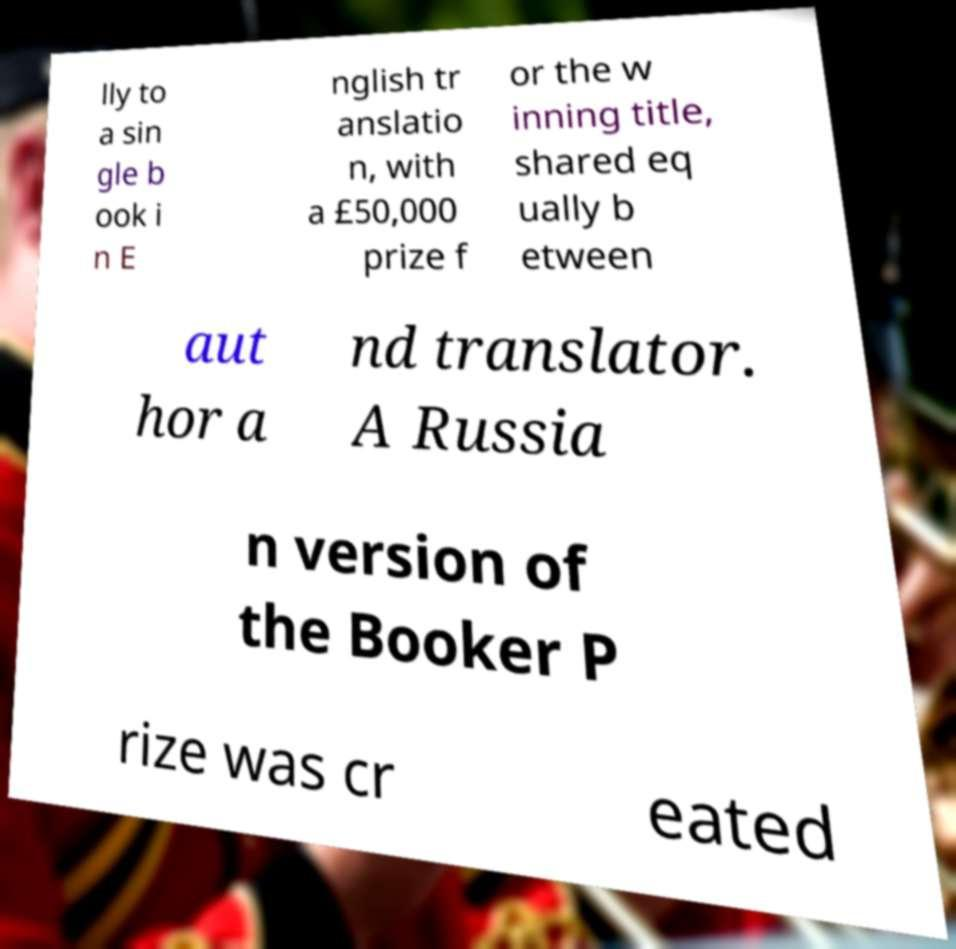Could you assist in decoding the text presented in this image and type it out clearly? lly to a sin gle b ook i n E nglish tr anslatio n, with a £50,000 prize f or the w inning title, shared eq ually b etween aut hor a nd translator. A Russia n version of the Booker P rize was cr eated 